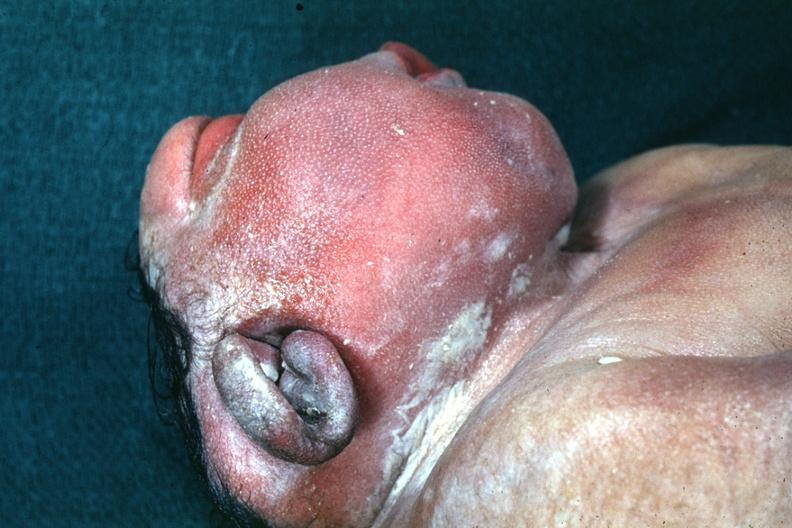s tuberculous peritonitis present?
Answer the question using a single word or phrase. No 